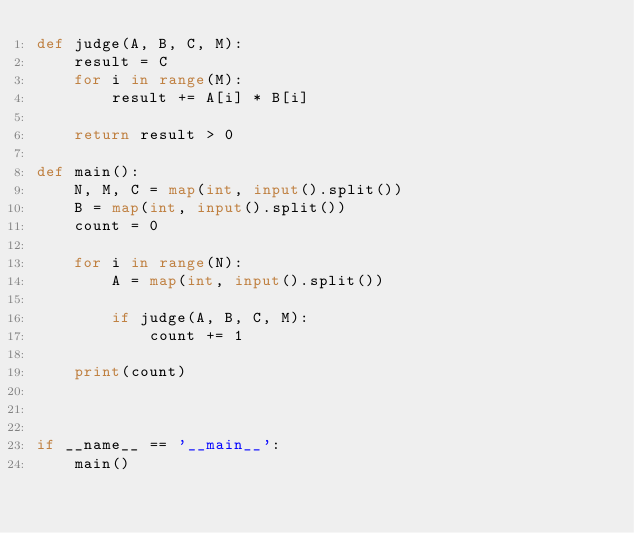Convert code to text. <code><loc_0><loc_0><loc_500><loc_500><_Python_>def judge(A, B, C, M):
	result = C
	for i in range(M):
		result += A[i] * B[i]

	return result > 0

def main():
	N, M, C = map(int, input().split())
	B = map(int, input().split())
	count = 0

	for i in range(N):
		A = map(int, input().split())

		if judge(A, B, C, M):
			count += 1

	print(count)



if __name__ == '__main__':
	main()</code> 